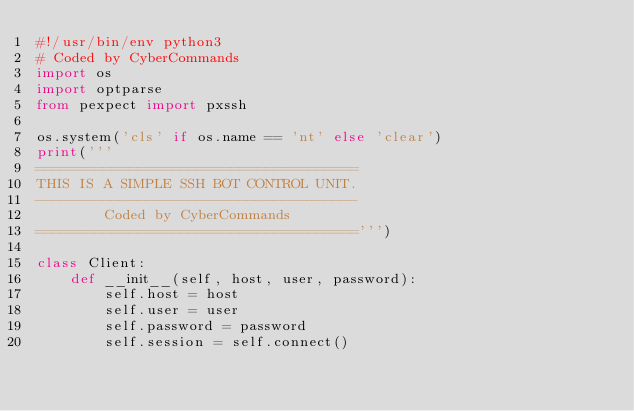Convert code to text. <code><loc_0><loc_0><loc_500><loc_500><_Python_>#!/usr/bin/env python3
# Coded by CyberCommands
import os
import optparse
from pexpect import pxssh

os.system('cls' if os.name == 'nt' else 'clear')
print('''
======================================
THIS IS A SIMPLE SSH BOT CONTROL UNIT.
--------------------------------------
        Coded by CyberCommands
======================================''')

class Client:
    def __init__(self, host, user, password):
        self.host = host
        self.user = user
        self.password = password
        self.session = self.connect()
    </code> 